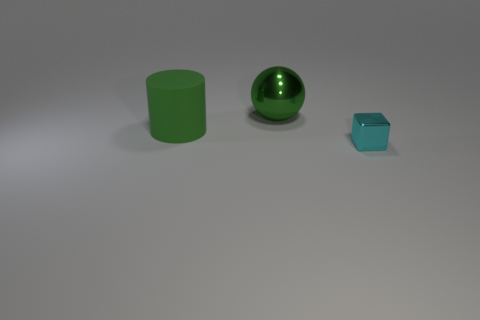The object that is the same color as the large metallic ball is what shape? The object that shares its green hue with the large metallic sphere exhibits a cubical form, perfect for portraying concepts of symmetry and balance. 